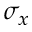Convert formula to latex. <formula><loc_0><loc_0><loc_500><loc_500>\sigma _ { x }</formula> 